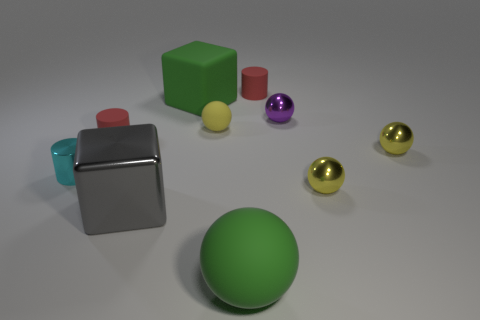Subtract all yellow spheres. How many were subtracted if there are1yellow spheres left? 2 Subtract all yellow balls. How many balls are left? 2 Subtract all cyan cylinders. How many cylinders are left? 2 Subtract 1 cylinders. How many cylinders are left? 2 Subtract all green cubes. How many red cylinders are left? 2 Subtract all cylinders. How many objects are left? 7 Subtract all cyan blocks. Subtract all cyan spheres. How many blocks are left? 2 Subtract all small shiny cylinders. Subtract all tiny metallic cylinders. How many objects are left? 8 Add 4 large gray cubes. How many large gray cubes are left? 5 Add 1 tiny cylinders. How many tiny cylinders exist? 4 